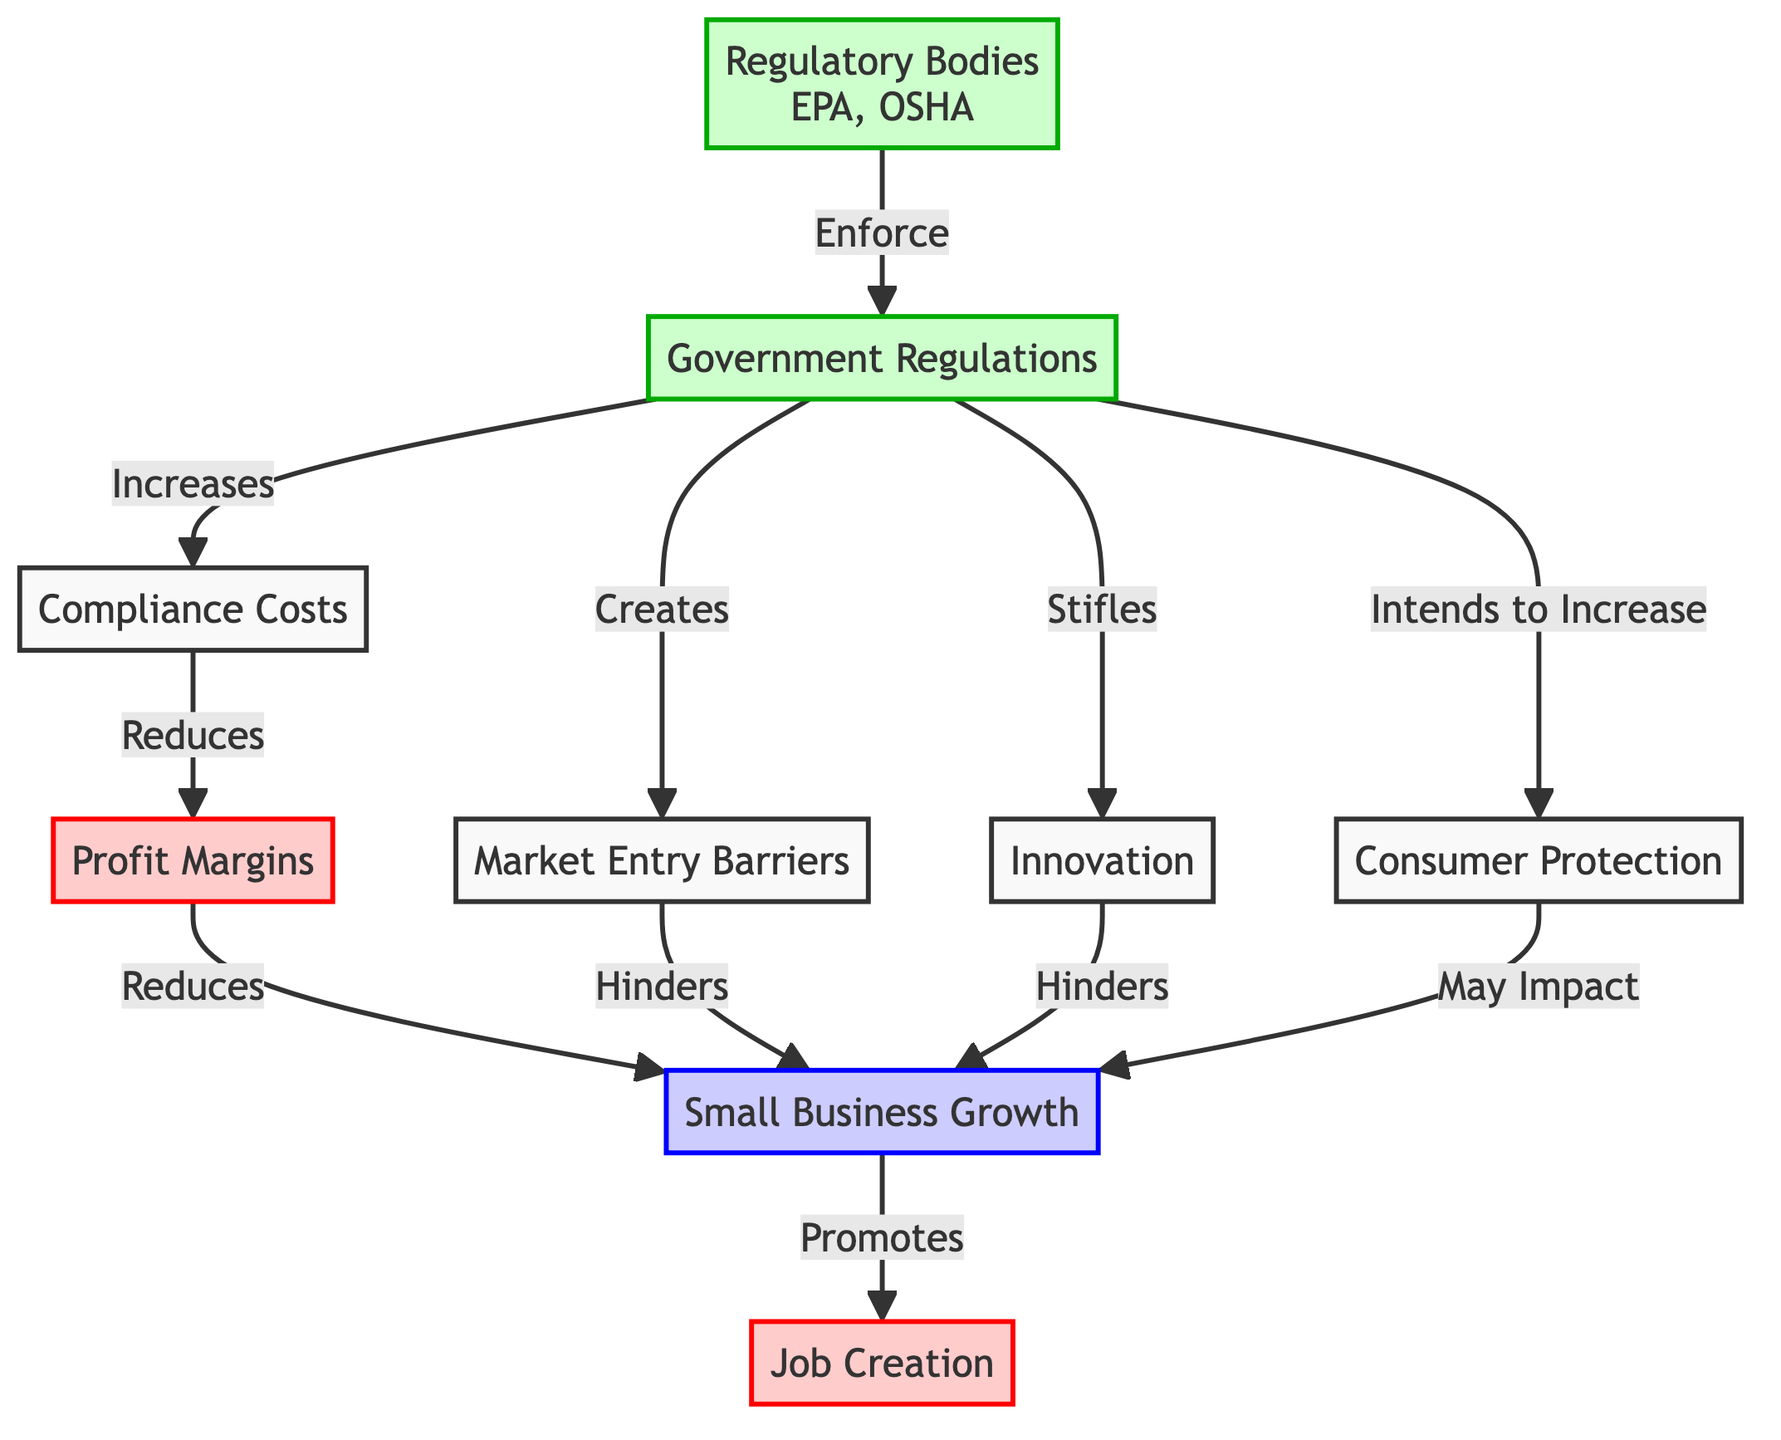What is the relationship between Government Regulations and Compliance Costs? The diagram shows a direct arrow from Government Regulations to Compliance Costs marked as "Increases." This indicates that Government Regulations lead to an increase in Compliance Costs.
Answer: Increases What effect do Compliance Costs have on Profit Margins? There is an arrow from Compliance Costs to Profit Margins labeled "Reduces." This means that increased Compliance Costs result in a reduction of Profit Margins.
Answer: Reduces How many direct impacts are shown from Government Regulations affecting Small Business Growth? By tracing the arrows from Government Regulations to Small Business Growth, there are three distinct paths: through Compliance Costs, Market Entry Barriers, and stifled Innovation. This results in a total of three direct impacts on Small Business Growth.
Answer: Three What role do Regulatory Bodies play according to the diagram? The diagram states that Regulatory Bodies enforce Government Regulations, showed by the arrow labeled "Enforce." Therefore, their role is to enforce regulations that influence the small business environment.
Answer: Enforce How does Innovation affect Small Business Growth? In the diagram, there is an arrow from Innovation to Small Business Growth labeled "Hinders." This means that stifled Innovation negatively impacts Small Business Growth.
Answer: Hinders What is the intended outcome of Government Regulations? The diagram indicates that Government Regulations intend to increase Consumer Protection, as shown by the arrow labeled "Intends to Increase."
Answer: Increase What is the outcome if Job Creation is promoted in Small Business Growth? From Small Business Growth, there is an arrow leading to Job Creation labeled "Promotes." This means if Small Business Growth occurs, it promotes Job Creation.
Answer: Promotes What can be inferred about the impact of Compliance Costs on Small Business Growth? The diagram has a clear connection through Compliance Costs which decreases Profit Margins, subsequently leading to a reduction in Small Business Growth. Therefore, high Compliance Costs negatively impact Small Business Growth.
Answer: Negatively Impact What is the effect of Market Entry Barriers on Small Business Growth? The diagram shows an arrow from Market Entry Barriers to Small Business Growth labeled "Hinders." This indicates that Market Entry Barriers hinder Small Business Growth.
Answer: Hinders 